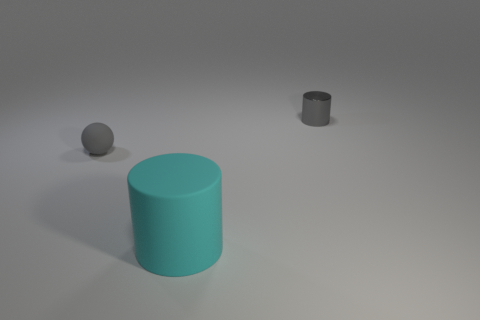Are there fewer things than big rubber cylinders? Based on the image, there are actually fewer large rubber cylinders than smaller objects. We can see one large cylinder, accompanied by a smaller cylinder and a small sphere. 